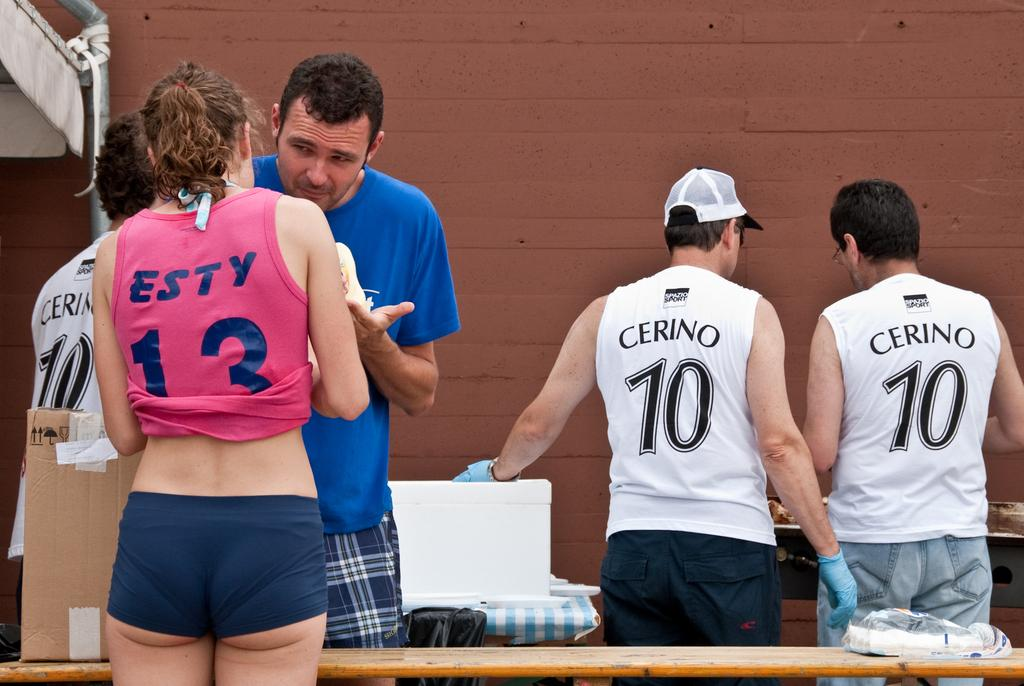Provide a one-sentence caption for the provided image. The backs of people with Cerino and Esty shirts. 